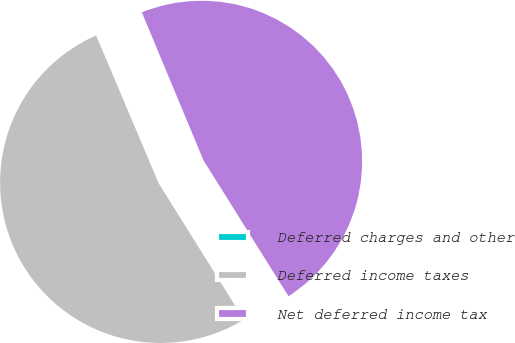<chart> <loc_0><loc_0><loc_500><loc_500><pie_chart><fcel>Deferred charges and other<fcel>Deferred income taxes<fcel>Net deferred income tax<nl><fcel>0.09%<fcel>52.52%<fcel>47.38%<nl></chart> 